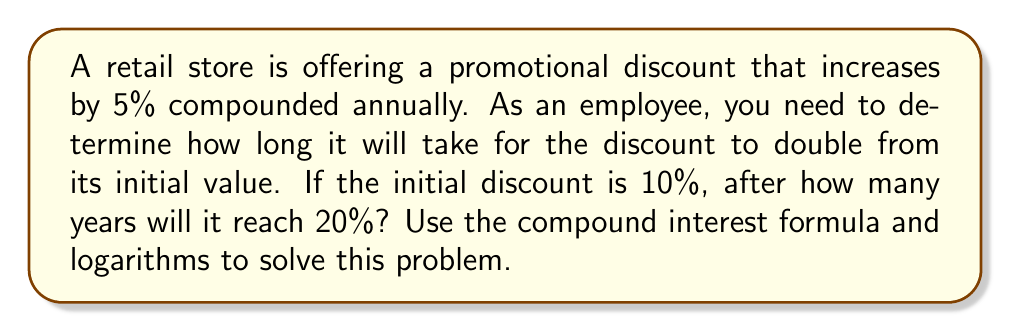Can you answer this question? Let's approach this step-by-step:

1) The compound interest formula is:
   $$A = P(1 + r)^t$$
   Where:
   $A$ = Final amount
   $P$ = Principal (initial amount)
   $r$ = Interest rate (as a decimal)
   $t$ = Time (in years)

2) In this case:
   $A = 20\%$ (the doubled discount)
   $P = 10\%$ (the initial discount)
   $r = 5\% = 0.05$ (the annual increase rate)
   $t$ = what we're solving for

3) Plugging these into the formula:
   $$20 = 10(1 + 0.05)^t$$

4) Divide both sides by 10:
   $$2 = (1.05)^t$$

5) Take the natural log of both sides:
   $$\ln(2) = \ln((1.05)^t)$$

6) Use the logarithm property $\ln(a^b) = b\ln(a)$:
   $$\ln(2) = t\ln(1.05)$$

7) Solve for $t$:
   $$t = \frac{\ln(2)}{\ln(1.05)}$$

8) Calculate:
   $$t \approx 14.2067$$

9) Since we're dealing with whole years, we round up to the next integer.
Answer: 15 years 